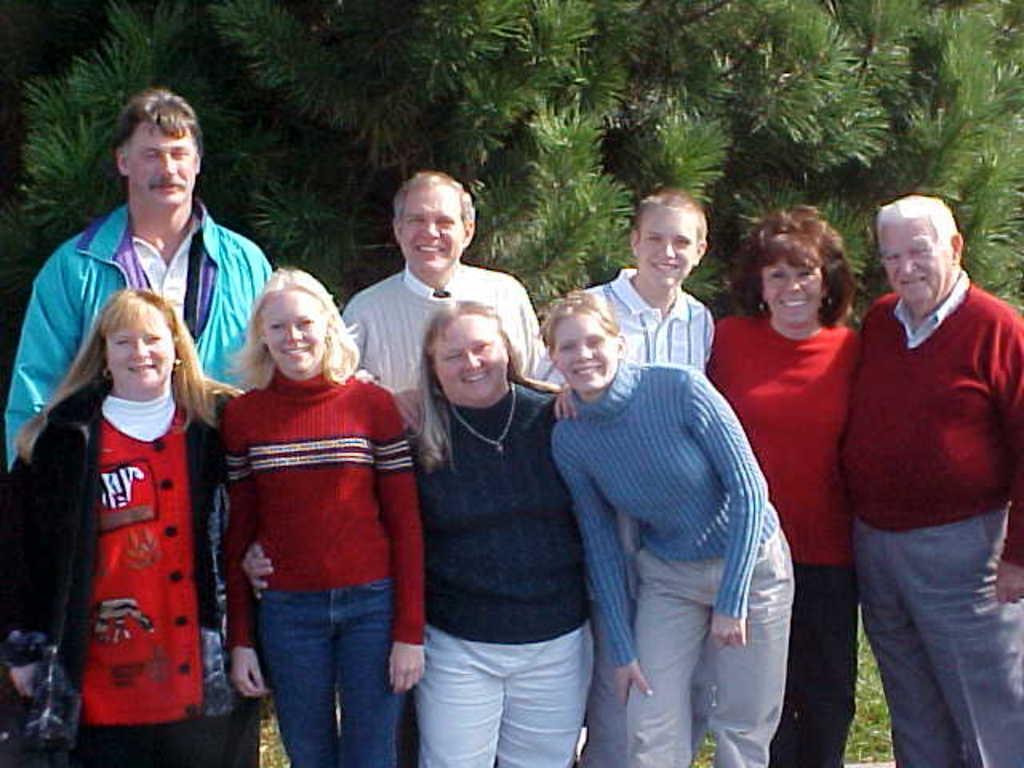In one or two sentences, can you explain what this image depicts? In this image I can see 4 girls are standing and smiling, behind them 5 persons are also standing and also smiling. behind them there are trees. 